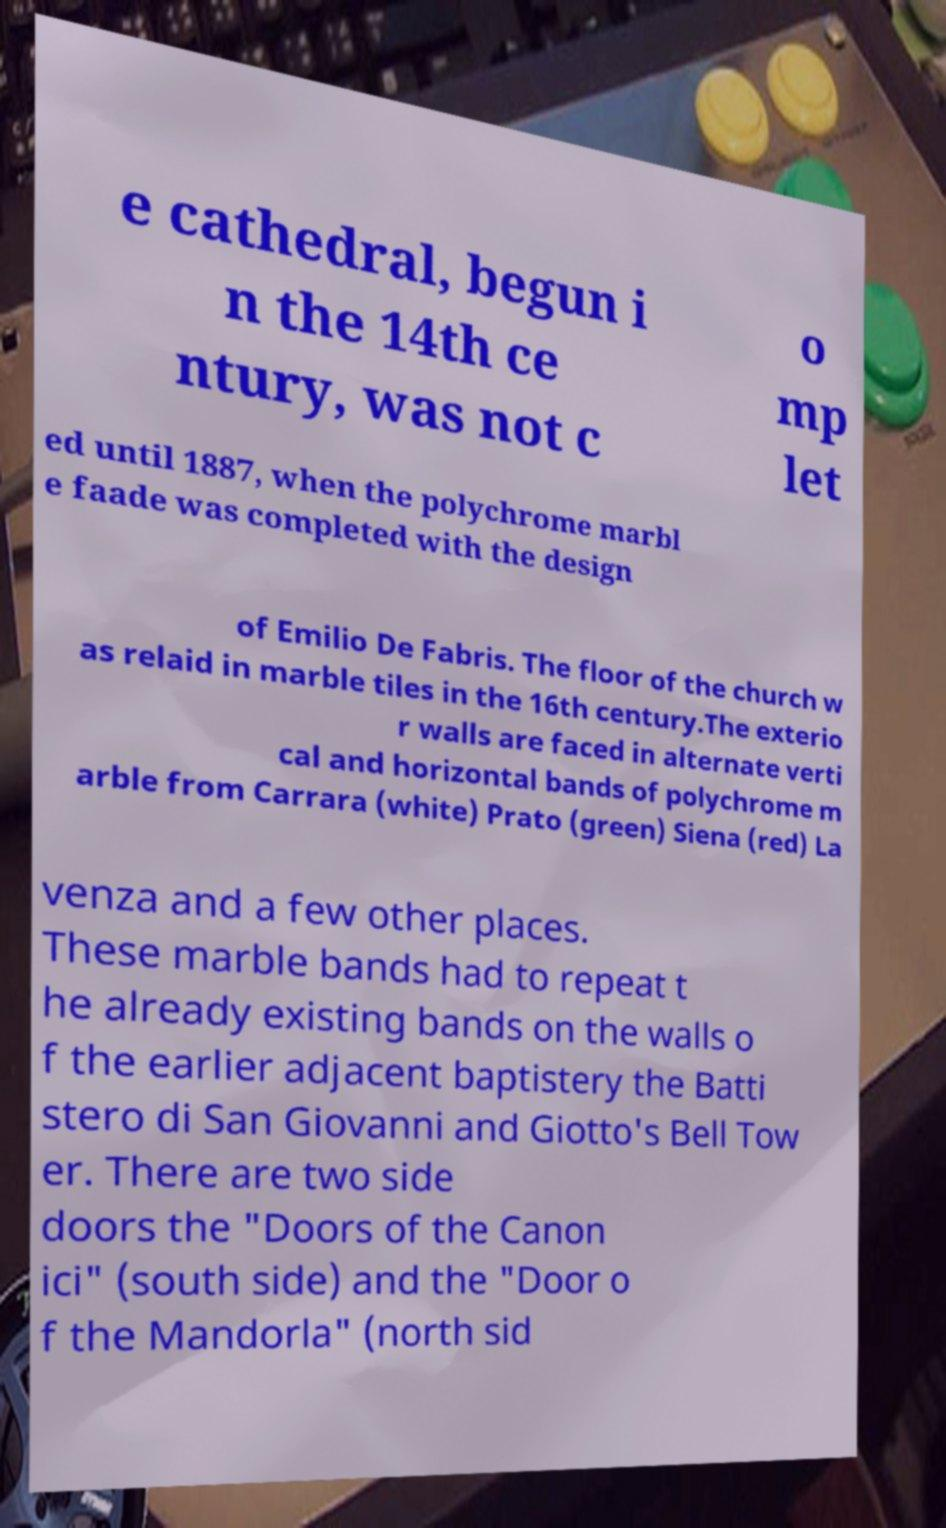I need the written content from this picture converted into text. Can you do that? e cathedral, begun i n the 14th ce ntury, was not c o mp let ed until 1887, when the polychrome marbl e faade was completed with the design of Emilio De Fabris. The floor of the church w as relaid in marble tiles in the 16th century.The exterio r walls are faced in alternate verti cal and horizontal bands of polychrome m arble from Carrara (white) Prato (green) Siena (red) La venza and a few other places. These marble bands had to repeat t he already existing bands on the walls o f the earlier adjacent baptistery the Batti stero di San Giovanni and Giotto's Bell Tow er. There are two side doors the "Doors of the Canon ici" (south side) and the "Door o f the Mandorla" (north sid 